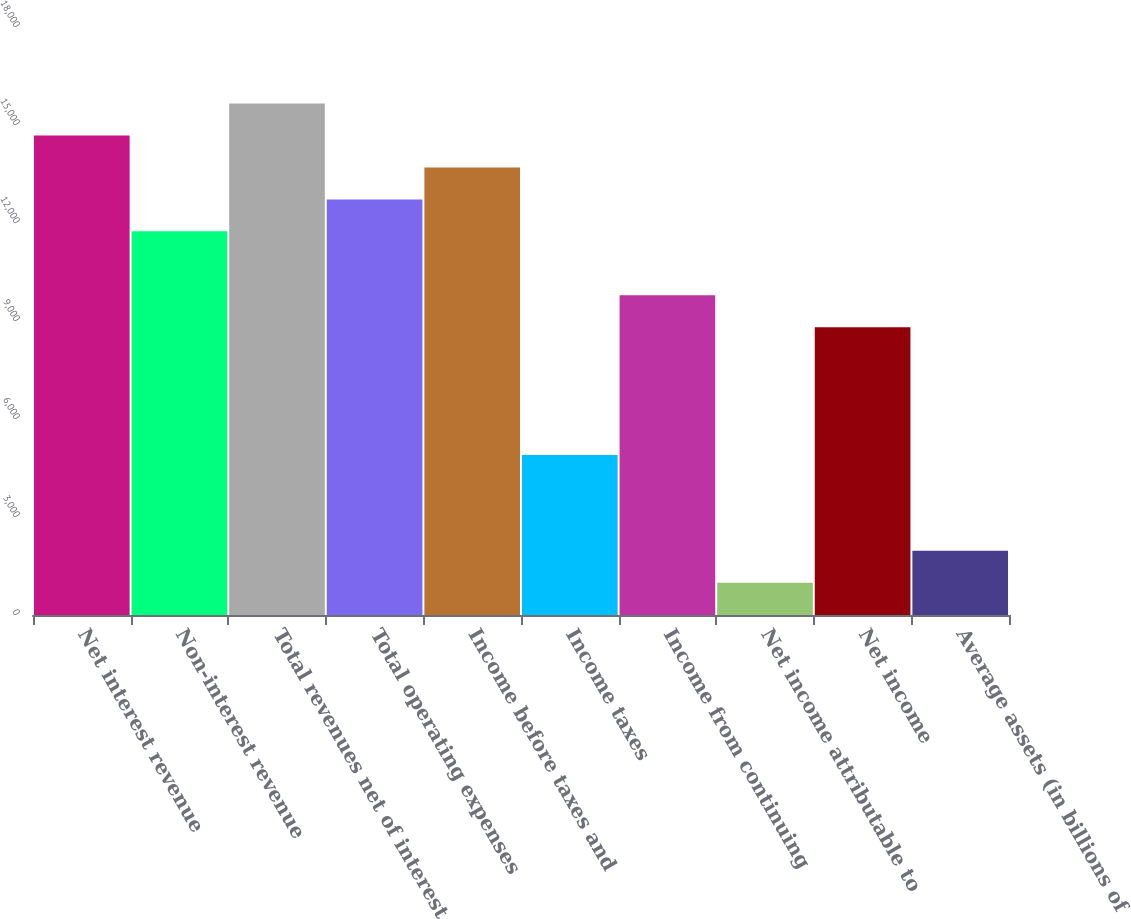Convert chart. <chart><loc_0><loc_0><loc_500><loc_500><bar_chart><fcel>Net interest revenue<fcel>Non-interest revenue<fcel>Total revenues net of interest<fcel>Total operating expenses<fcel>Income before taxes and<fcel>Income taxes<fcel>Income from continuing<fcel>Net income attributable to<fcel>Net income<fcel>Average assets (in billions of<nl><fcel>14677.5<fcel>11744.4<fcel>15655.1<fcel>12722.1<fcel>13699.8<fcel>4900.55<fcel>9789<fcel>989.79<fcel>8811.31<fcel>1967.48<nl></chart> 